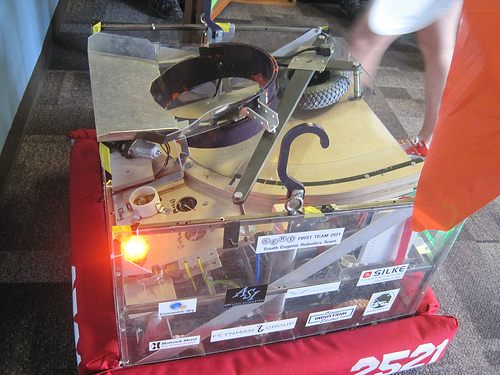<image>
Is the sticker behind the box? No. The sticker is not behind the box. From this viewpoint, the sticker appears to be positioned elsewhere in the scene. 